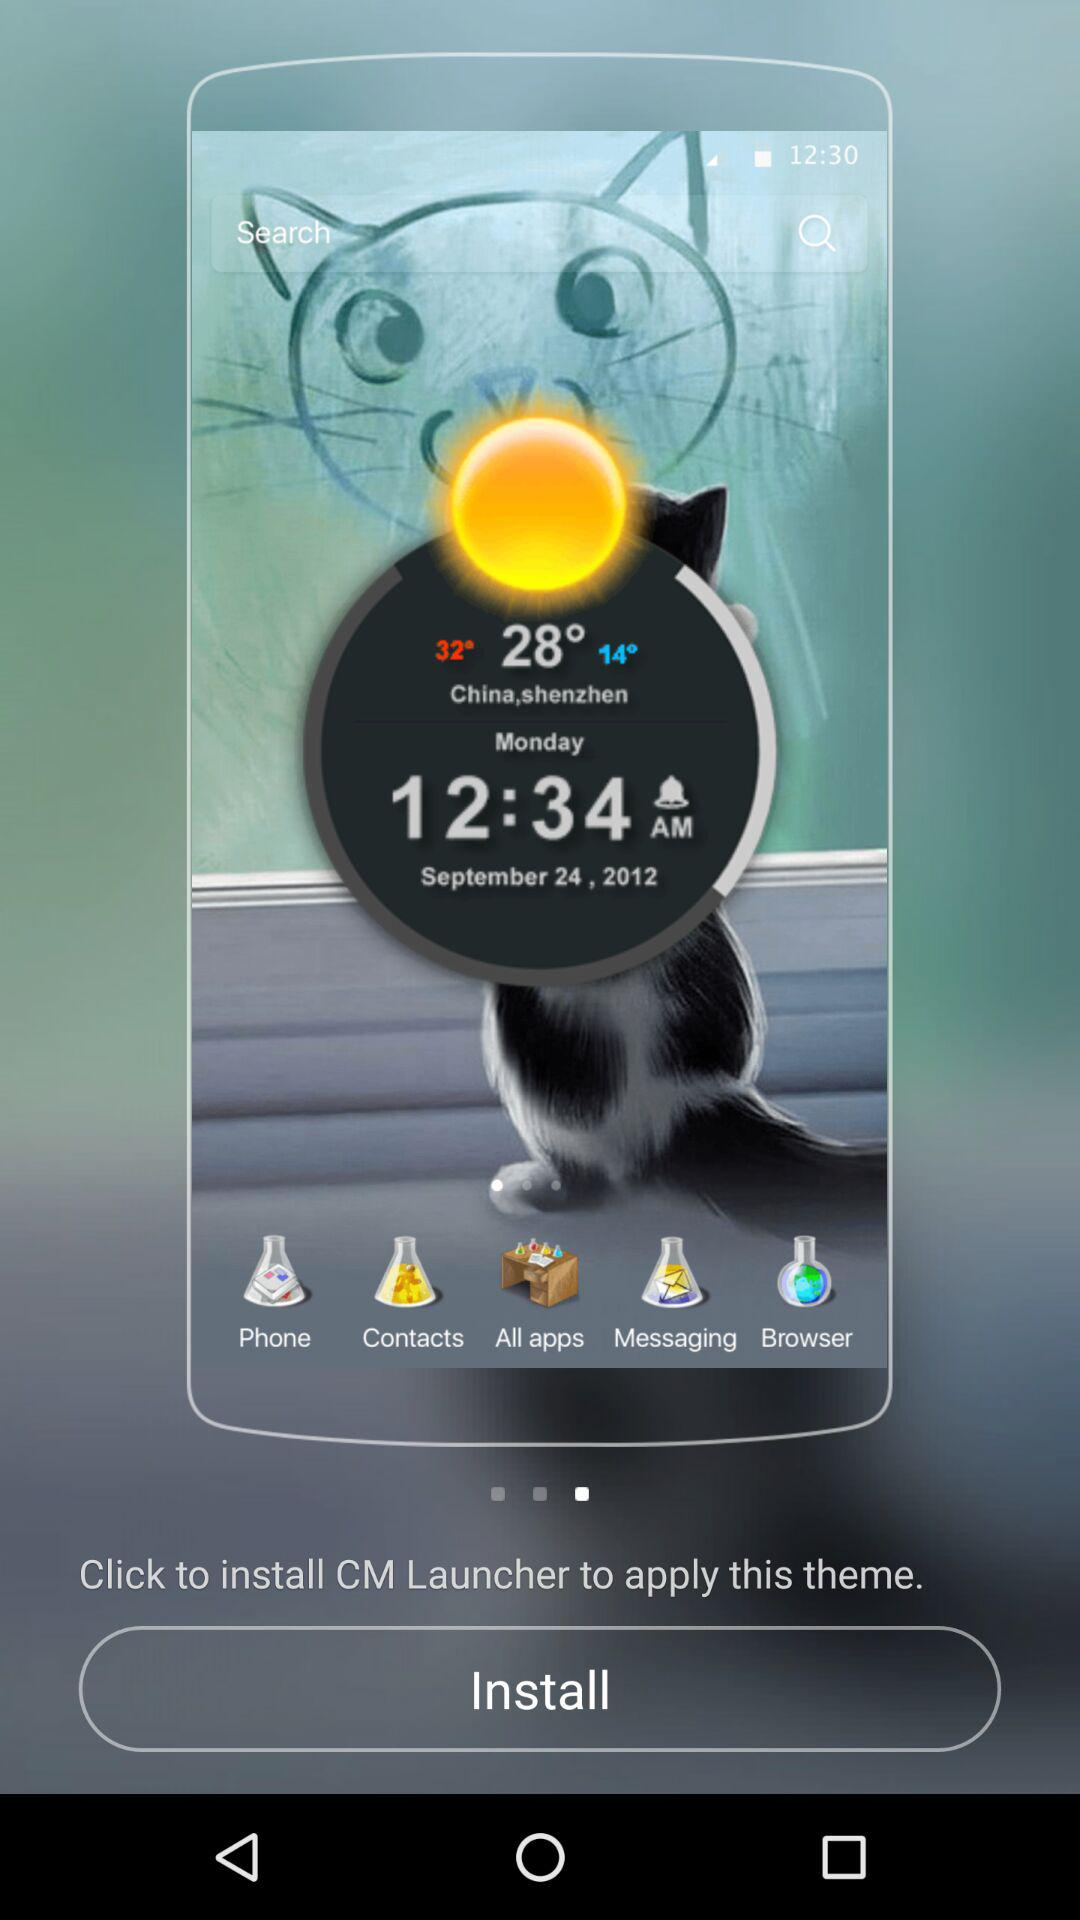What is the date? The date is September 24, 2012. 